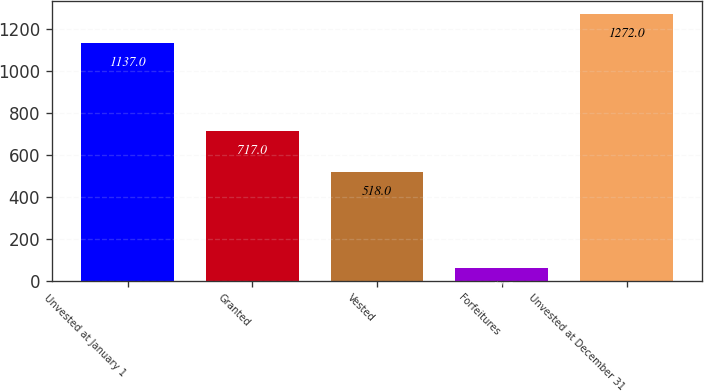<chart> <loc_0><loc_0><loc_500><loc_500><bar_chart><fcel>Unvested at January 1<fcel>Granted<fcel>Vested<fcel>Forfeitures<fcel>Unvested at December 31<nl><fcel>1137<fcel>717<fcel>518<fcel>64<fcel>1272<nl></chart> 